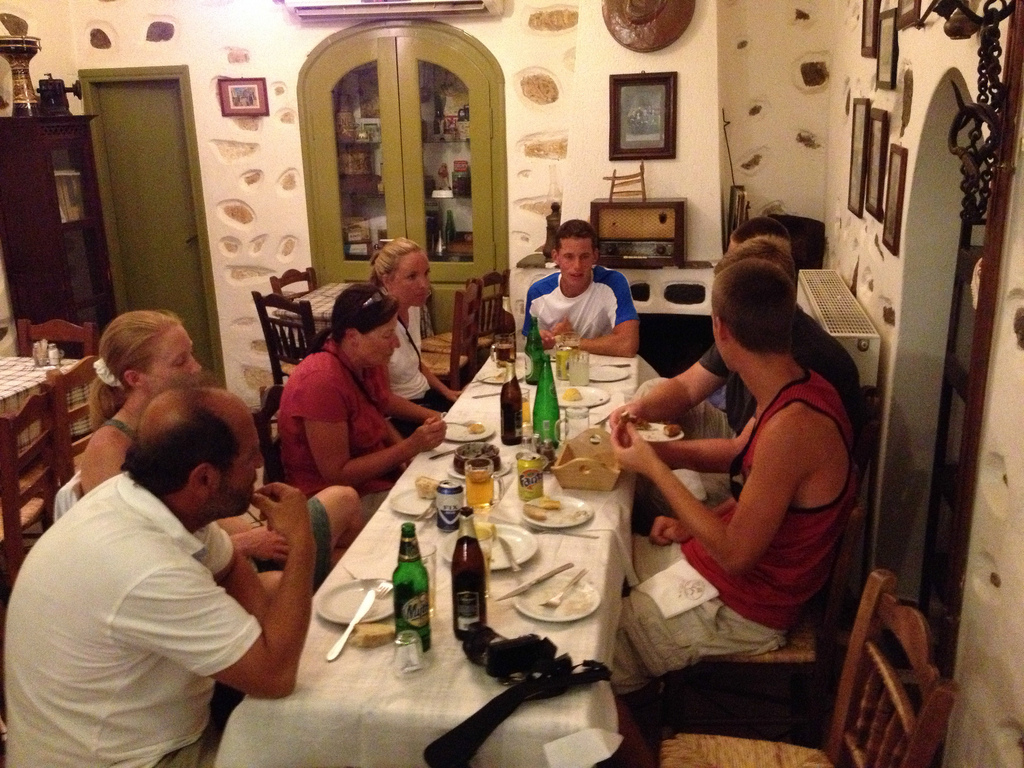Do the people to the left of the woman seem to be walking? No, the people to the left of the woman are seated at the table, enjoying their food and drinks. 